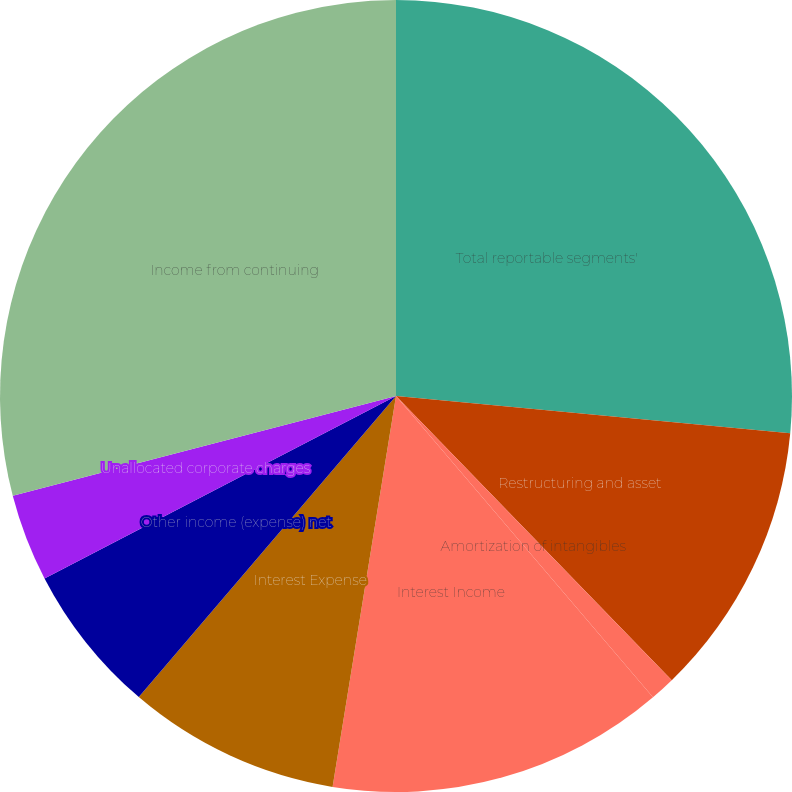Convert chart. <chart><loc_0><loc_0><loc_500><loc_500><pie_chart><fcel>Total reportable segments'<fcel>Restructuring and asset<fcel>Amortization of intangibles<fcel>Interest Income<fcel>Interest Expense<fcel>Other income (expense) net<fcel>Unallocated corporate charges<fcel>Income from continuing<nl><fcel>26.5%<fcel>11.24%<fcel>1.02%<fcel>13.8%<fcel>8.69%<fcel>6.13%<fcel>3.57%<fcel>29.05%<nl></chart> 